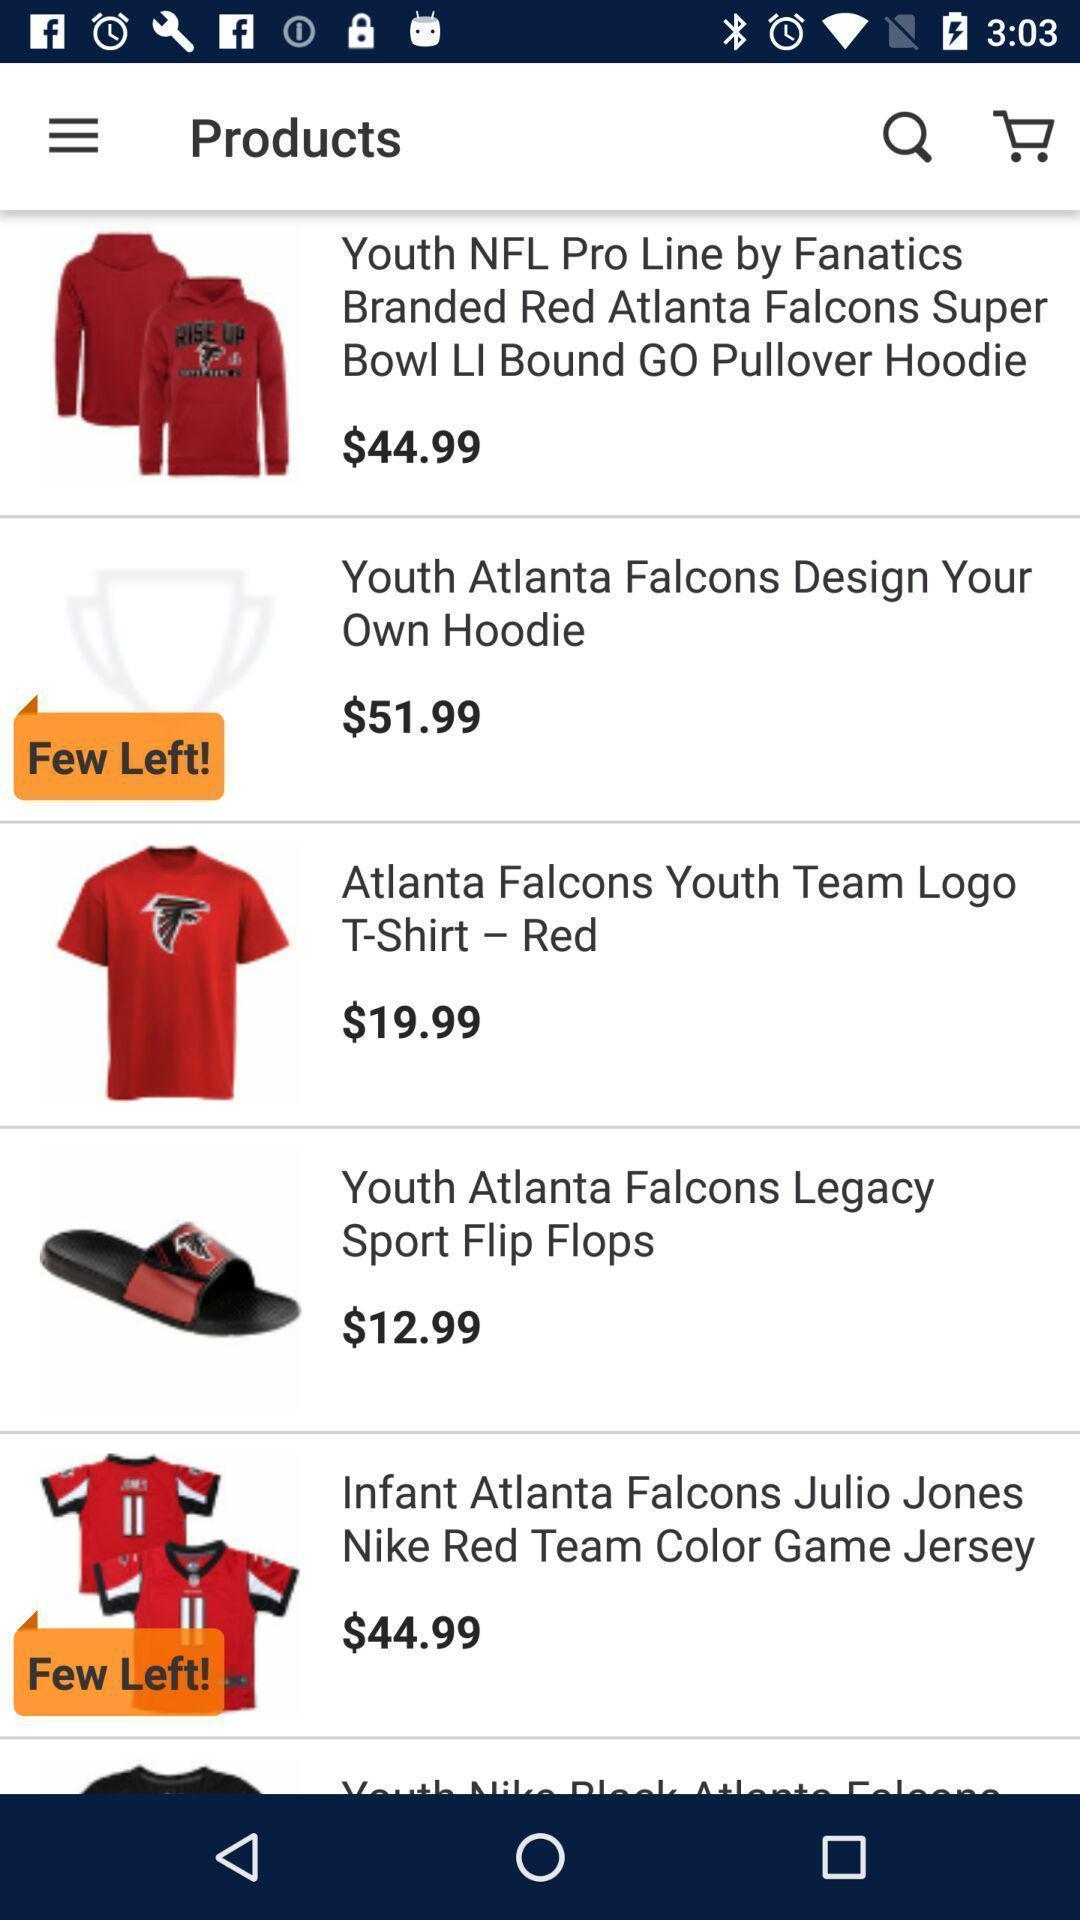Summarize the main components in this picture. Page showing various products on shopping app. 